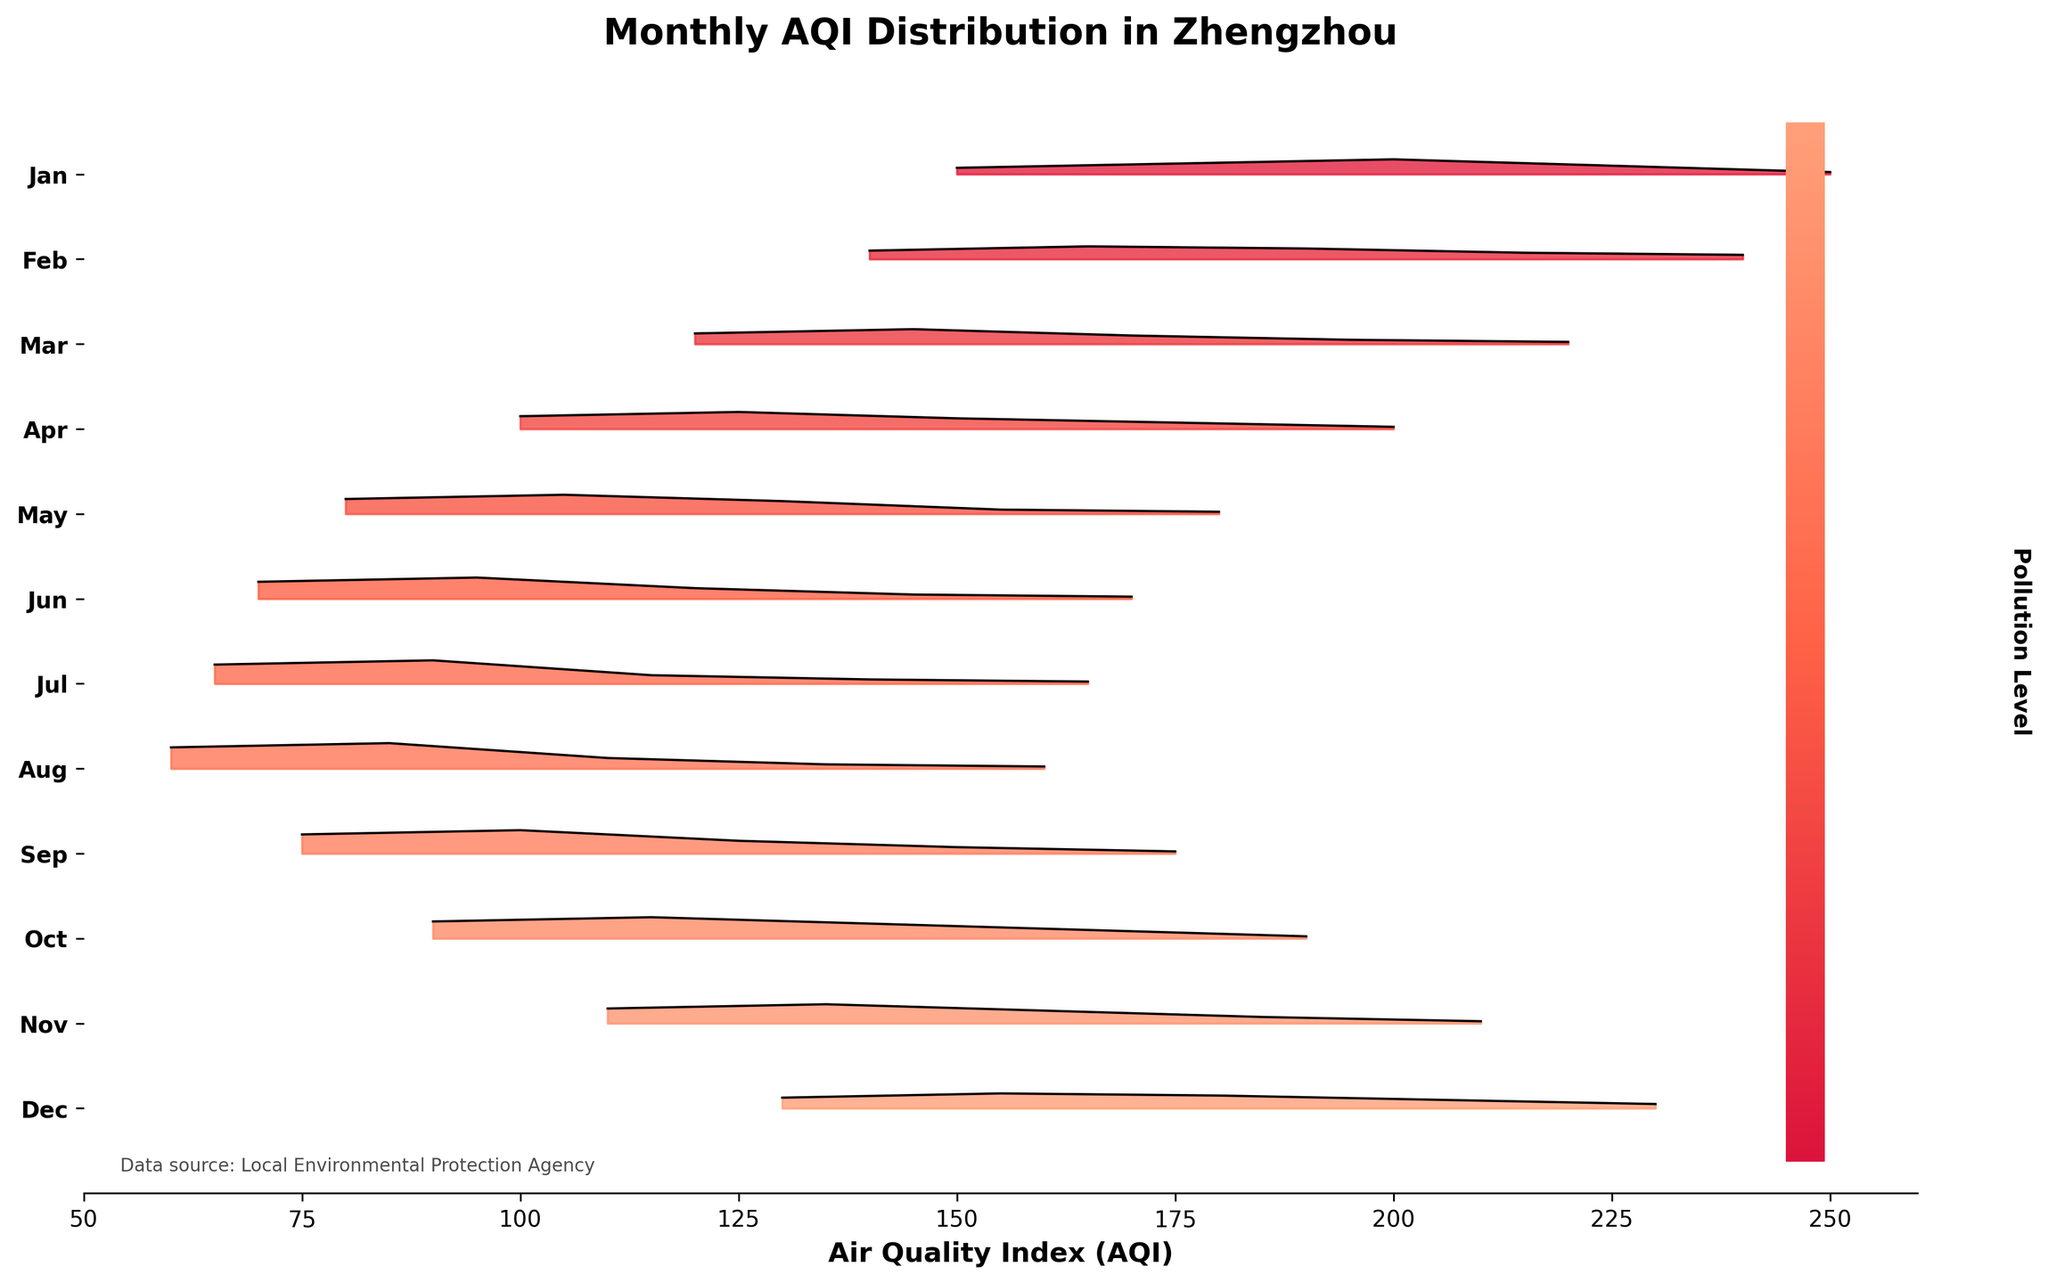What is the title of the plot? The title is prominently displayed at the top of the plot stating its purpose.
Answer: Monthly AQI Distribution in Zhengzhou Which month shows the highest AQI density at 90? By observing the plot, look at the y-ticks and identify the month corresponding to the highest density peak at AQI 90.
Answer: October How does the AQI distribution differ between January and June? Compare the spread and peak values of the AQI distributions for both months by looking at their positions on the y-axis. January has higher AQI values (above 150), while June has lower AQI values (between 70 and 145).
Answer: January has higher AQI values, June has lower AQI values In which month is the AQI most concentrated around 85? Identify the month where there is a noticeable peak in density at AQI 85 by looking at the corresponding position on the y-axis.
Answer: August What is the common AQI range during August? Look at the AQI values where the density peaks in August. The range is identified by the high densities at specific AQI levels, which is from 60 to 110.
Answer: 60 to 110 Which month has the smallest range of AQI values? Evaluate the spread of AQI values for each month; the month with the smallest range will have the densest and narrowest distribution.
Answer: July How does the AQI in April compare to May in terms of density peaks? Compare the density peaks for April and May by looking at their AQI values and how high their peaks are. Both months have peaks around AQI 100-105, but May has a higher density peak at these values.
Answer: May has higher density peaks In which months does the AQI never go below 100? Identify the months on the y-axis that do not have any portions of their density distributions below an AQI of 100.
Answer: January and February Which month shows the broadest distribution in AQI values? Look for the month with the widest spread in AQI density distributions from low to high AQI values.
Answer: December During which month is the AQI most frequently below 80? Identify the month where there is a significant density below the AQI value of 80 by examining the positions on the y-axis.
Answer: June 